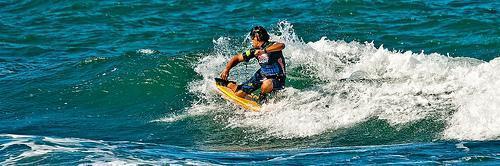How many people are in the pic?
Give a very brief answer. 1. 